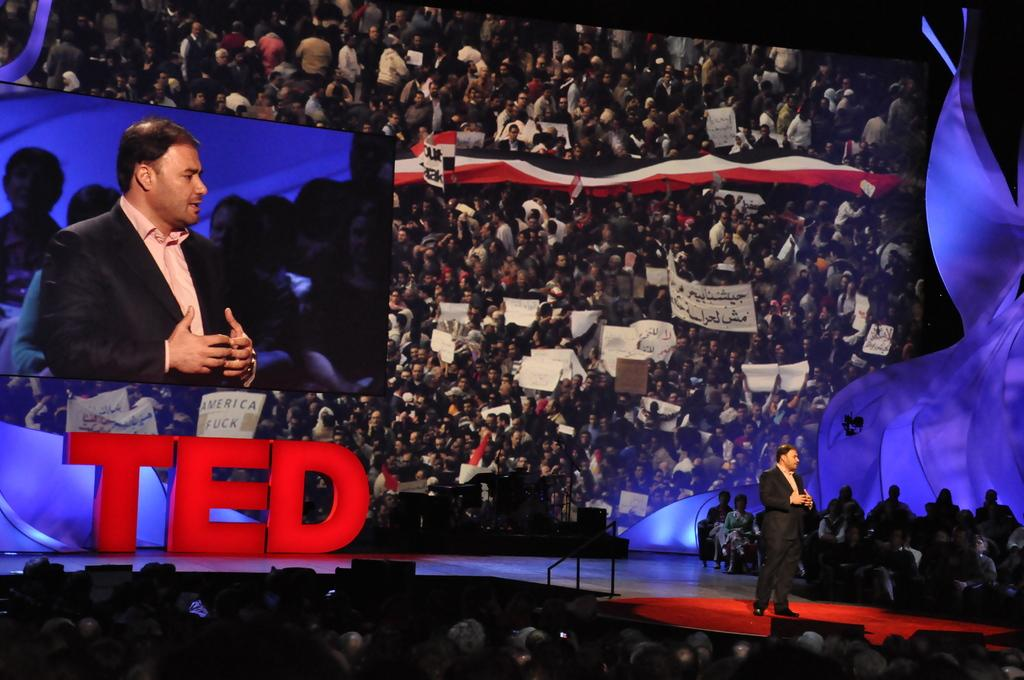What is the position of the man in the image? There is a man standing on the right side of the image. What can be seen at the bottom of the image? There is a crowd at the bottom of the image. What is located on the left side of the image? There is a screen on the left side of the image. What is visible in the background of the image? There is a board in the background of the image. How many balloons are being exchanged in the image? There are no balloons present in the image. 